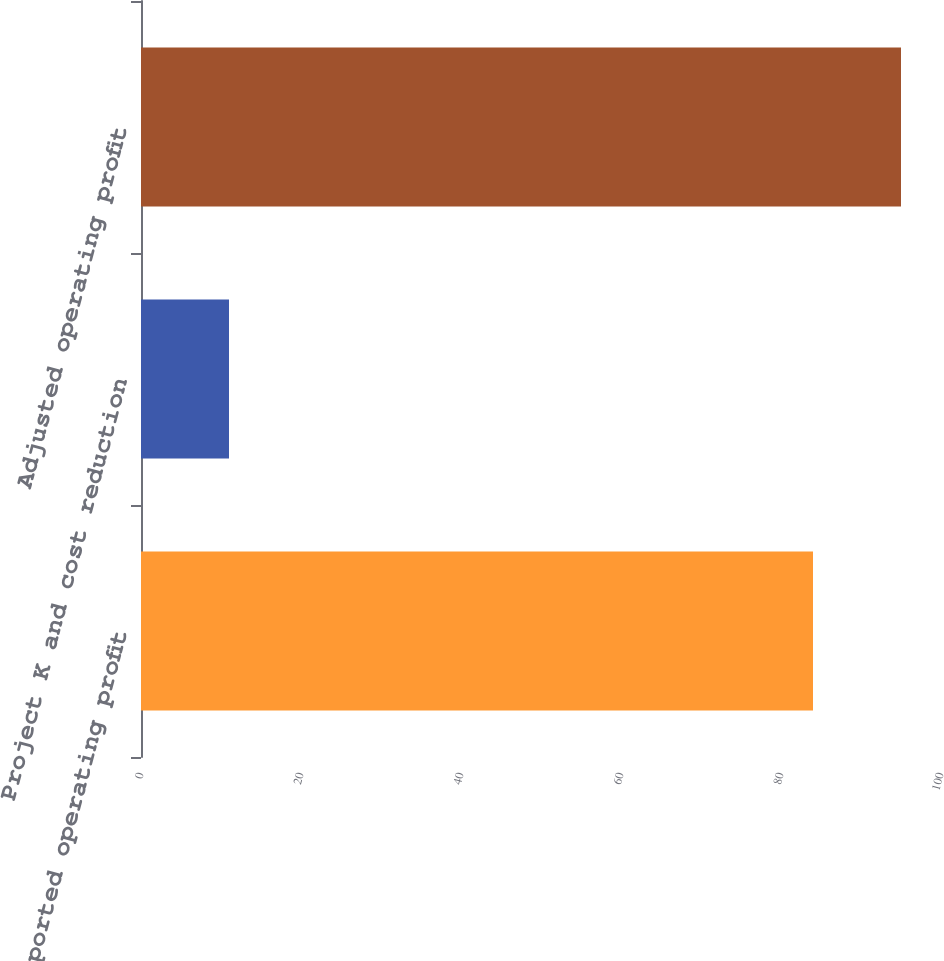<chart> <loc_0><loc_0><loc_500><loc_500><bar_chart><fcel>Reported operating profit<fcel>Project K and cost reduction<fcel>Adjusted operating profit<nl><fcel>84<fcel>11<fcel>95<nl></chart> 